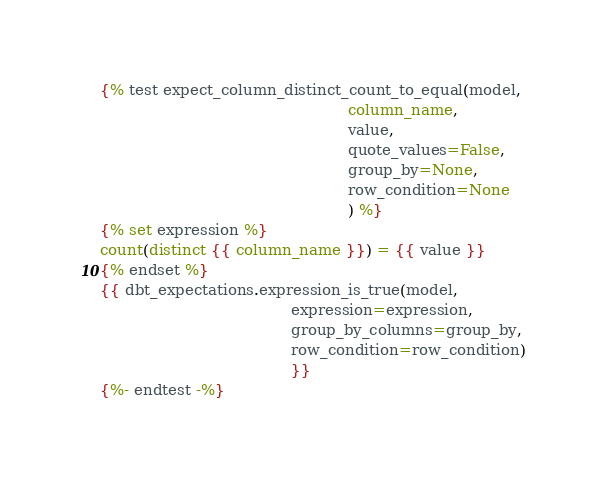Convert code to text. <code><loc_0><loc_0><loc_500><loc_500><_SQL_>{% test expect_column_distinct_count_to_equal(model,
                                                    column_name,
                                                    value,
                                                    quote_values=False,
                                                    group_by=None,
                                                    row_condition=None
                                                    ) %}
{% set expression %}
count(distinct {{ column_name }}) = {{ value }}
{% endset %}
{{ dbt_expectations.expression_is_true(model,
                                        expression=expression,
                                        group_by_columns=group_by,
                                        row_condition=row_condition)
                                        }}
{%- endtest -%}
</code> 